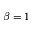Convert formula to latex. <formula><loc_0><loc_0><loc_500><loc_500>\beta = 1</formula> 